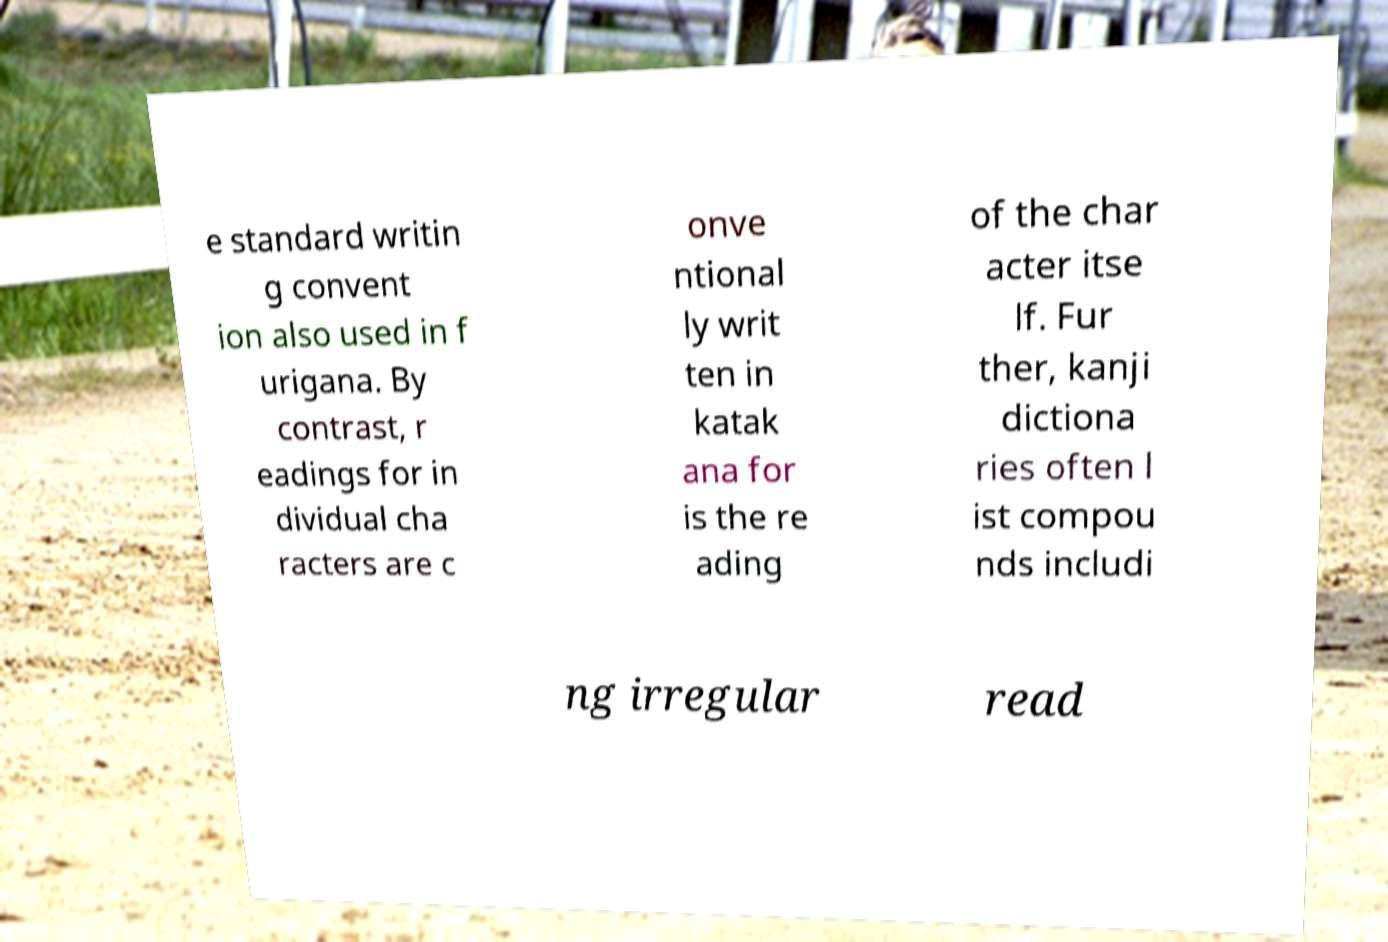Please identify and transcribe the text found in this image. e standard writin g convent ion also used in f urigana. By contrast, r eadings for in dividual cha racters are c onve ntional ly writ ten in katak ana for is the re ading of the char acter itse lf. Fur ther, kanji dictiona ries often l ist compou nds includi ng irregular read 